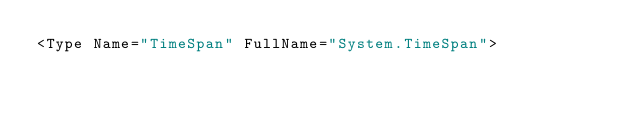<code> <loc_0><loc_0><loc_500><loc_500><_XML_><Type Name="TimeSpan" FullName="System.TimeSpan"></code> 